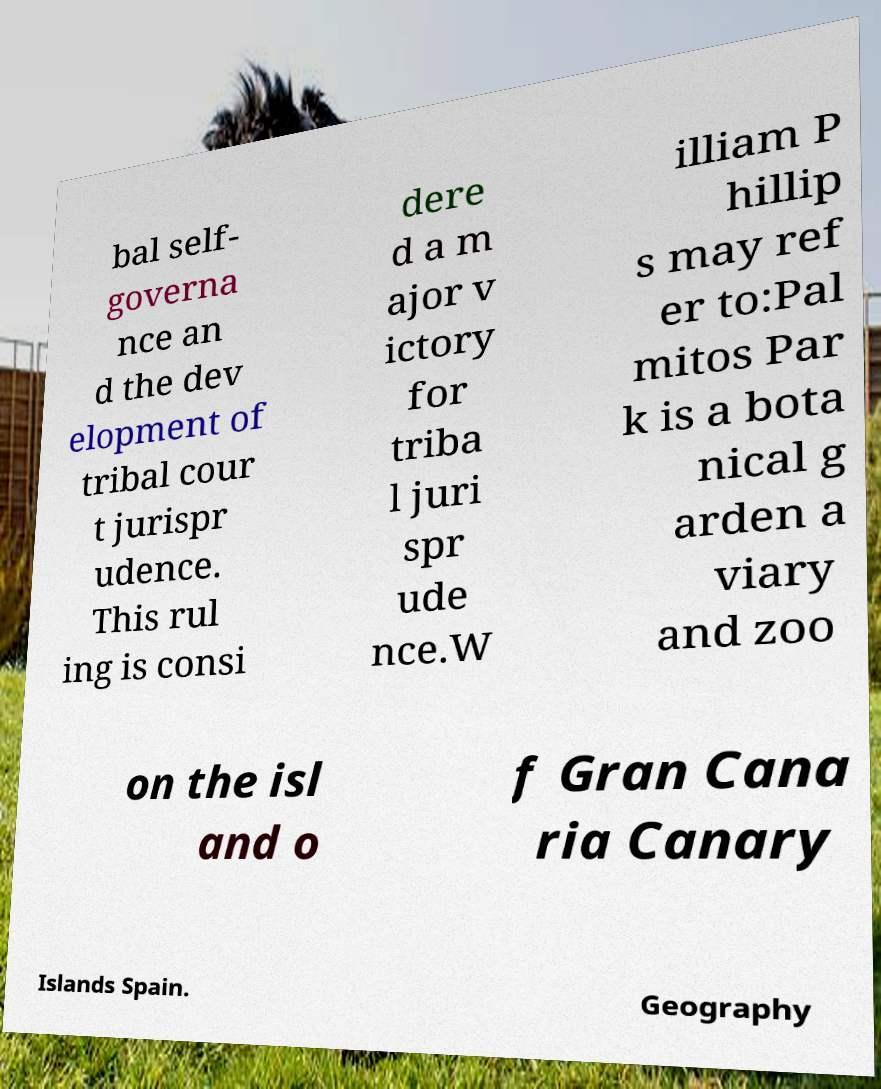Could you extract and type out the text from this image? bal self- governa nce an d the dev elopment of tribal cour t jurispr udence. This rul ing is consi dere d a m ajor v ictory for triba l juri spr ude nce.W illiam P hillip s may ref er to:Pal mitos Par k is a bota nical g arden a viary and zoo on the isl and o f Gran Cana ria Canary Islands Spain. Geography 